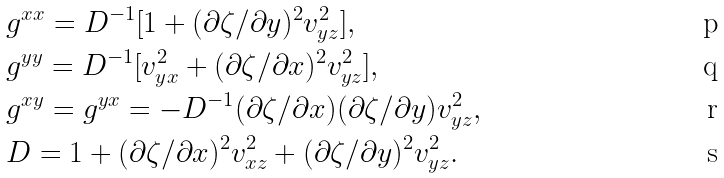<formula> <loc_0><loc_0><loc_500><loc_500>& g ^ { x x } = D ^ { - 1 } [ 1 + ( \partial \zeta / \partial y ) ^ { 2 } v _ { y z } ^ { 2 } ] , \\ & g ^ { y y } = D ^ { - 1 } [ v _ { y x } ^ { 2 } + ( \partial \zeta / \partial x ) ^ { 2 } v _ { y z } ^ { 2 } ] , \\ & g ^ { x y } = g ^ { y x } = - D ^ { - 1 } ( \partial \zeta / \partial x ) ( \partial \zeta / \partial y ) v _ { y z } ^ { 2 } , \\ & D = 1 + ( \partial \zeta / \partial x ) ^ { 2 } v _ { x z } ^ { 2 } + ( \partial \zeta / \partial y ) ^ { 2 } v _ { y z } ^ { 2 } .</formula> 